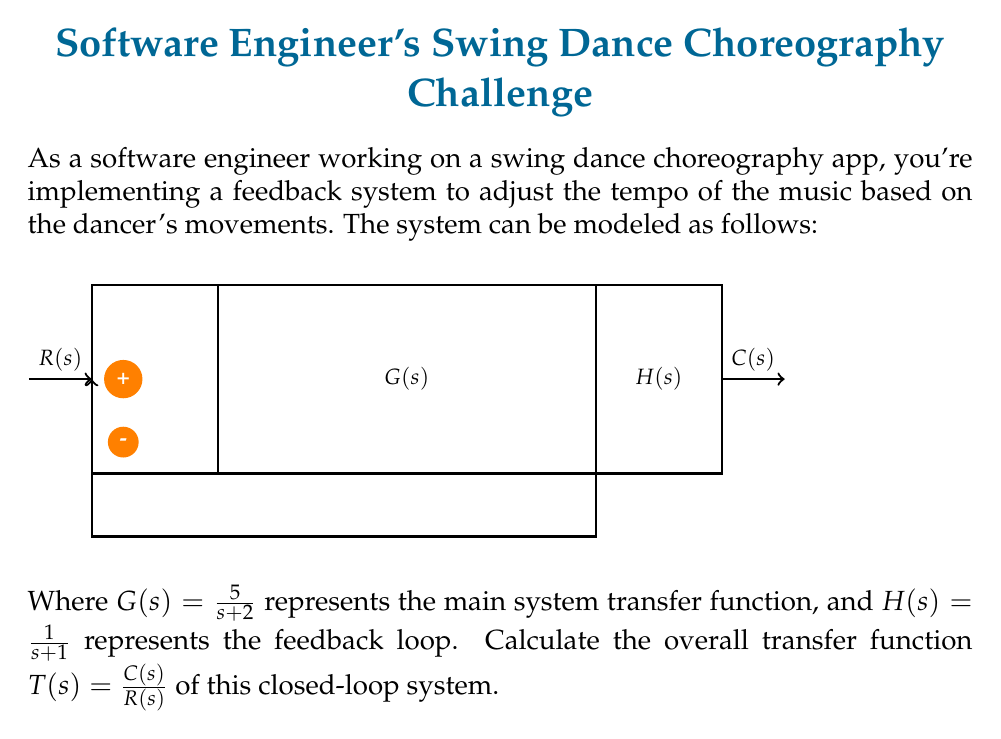Help me with this question. Let's approach this step-by-step:

1) In a closed-loop system with negative feedback, the general form of the transfer function is:

   $$T(s) = \frac{G(s)}{1 + G(s)H(s)}$$

2) We're given:
   $G(s) = \frac{5}{s+2}$
   $H(s) = \frac{1}{s+1}$

3) Let's substitute these into our general form:

   $$T(s) = \frac{\frac{5}{s+2}}{1 + \frac{5}{s+2} \cdot \frac{1}{s+1}}$$

4) To simplify this, let's first multiply the numerator and denominator of the fraction in the denominator:

   $$T(s) = \frac{\frac{5}{s+2}}{1 + \frac{5}{(s+2)(s+1)}}$$

5) Now, let's find a common denominator for the fraction in the denominator:

   $$T(s) = \frac{\frac{5}{s+2}}{\frac{(s+2)(s+1) + 5}{(s+2)(s+1)}}$$

6) Simplify the numerator of the fraction in the denominator:

   $$T(s) = \frac{\frac{5}{s+2}}{\frac{s^2 + 3s + 2 + 5}{(s+2)(s+1)}} = \frac{\frac{5}{s+2}}{\frac{s^2 + 3s + 7}{(s+2)(s+1)}}$$

7) Now, we can invert the division in the denominator:

   $$T(s) = \frac{5}{s+2} \cdot \frac{(s+2)(s+1)}{s^2 + 3s + 7}$$

8) The $(s+2)$ terms cancel out:

   $$T(s) = \frac{5(s+1)}{s^2 + 3s + 7}$$

This is our final transfer function.
Answer: $$T(s) = \frac{5(s+1)}{s^2 + 3s + 7}$$ 